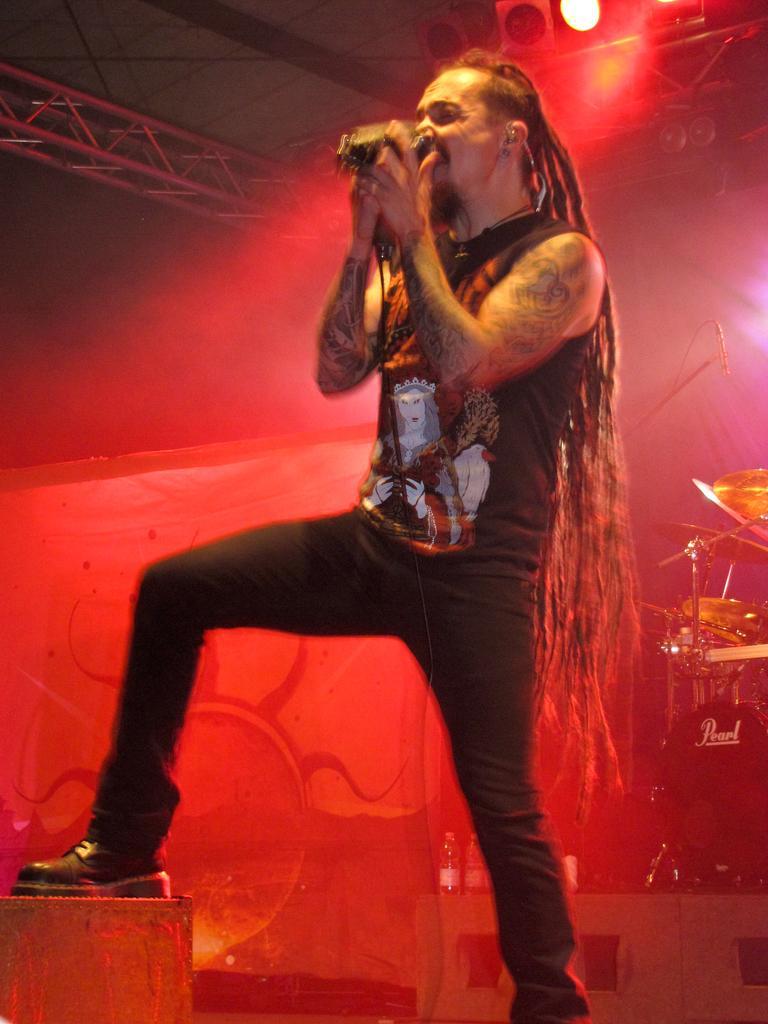Could you give a brief overview of what you see in this image? In this image, we can see a person wearing clothes and holding a mic with his hands. There are musical instruments on the right side of the image. There is a light at the top of the image. There is a metal frame in the top left of the image. 